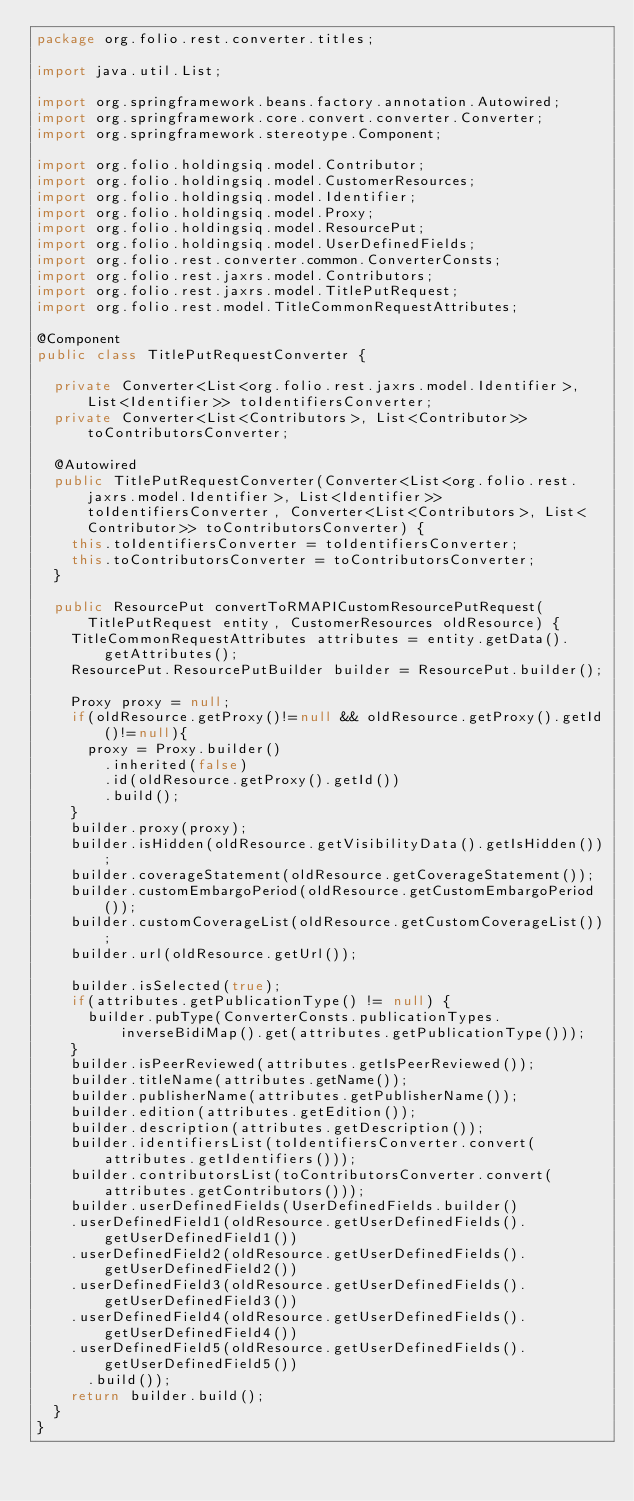Convert code to text. <code><loc_0><loc_0><loc_500><loc_500><_Java_>package org.folio.rest.converter.titles;

import java.util.List;

import org.springframework.beans.factory.annotation.Autowired;
import org.springframework.core.convert.converter.Converter;
import org.springframework.stereotype.Component;

import org.folio.holdingsiq.model.Contributor;
import org.folio.holdingsiq.model.CustomerResources;
import org.folio.holdingsiq.model.Identifier;
import org.folio.holdingsiq.model.Proxy;
import org.folio.holdingsiq.model.ResourcePut;
import org.folio.holdingsiq.model.UserDefinedFields;
import org.folio.rest.converter.common.ConverterConsts;
import org.folio.rest.jaxrs.model.Contributors;
import org.folio.rest.jaxrs.model.TitlePutRequest;
import org.folio.rest.model.TitleCommonRequestAttributes;

@Component
public class TitlePutRequestConverter {

  private Converter<List<org.folio.rest.jaxrs.model.Identifier>, List<Identifier>> toIdentifiersConverter;
  private Converter<List<Contributors>, List<Contributor>> toContributorsConverter;

  @Autowired
  public TitlePutRequestConverter(Converter<List<org.folio.rest.jaxrs.model.Identifier>, List<Identifier>> toIdentifiersConverter, Converter<List<Contributors>, List<Contributor>> toContributorsConverter) {
    this.toIdentifiersConverter = toIdentifiersConverter;
    this.toContributorsConverter = toContributorsConverter;
  }

  public ResourcePut convertToRMAPICustomResourcePutRequest(TitlePutRequest entity, CustomerResources oldResource) {
    TitleCommonRequestAttributes attributes = entity.getData().getAttributes();
    ResourcePut.ResourcePutBuilder builder = ResourcePut.builder();

    Proxy proxy = null;
    if(oldResource.getProxy()!=null && oldResource.getProxy().getId()!=null){
      proxy = Proxy.builder()
        .inherited(false)
        .id(oldResource.getProxy().getId())
        .build();
    }
    builder.proxy(proxy);
    builder.isHidden(oldResource.getVisibilityData().getIsHidden());
    builder.coverageStatement(oldResource.getCoverageStatement());
    builder.customEmbargoPeriod(oldResource.getCustomEmbargoPeriod());
    builder.customCoverageList(oldResource.getCustomCoverageList());
    builder.url(oldResource.getUrl());

    builder.isSelected(true);
    if(attributes.getPublicationType() != null) {
      builder.pubType(ConverterConsts.publicationTypes.inverseBidiMap().get(attributes.getPublicationType()));
    }
    builder.isPeerReviewed(attributes.getIsPeerReviewed());
    builder.titleName(attributes.getName());
    builder.publisherName(attributes.getPublisherName());
    builder.edition(attributes.getEdition());
    builder.description(attributes.getDescription());
    builder.identifiersList(toIdentifiersConverter.convert(attributes.getIdentifiers()));
    builder.contributorsList(toContributorsConverter.convert(attributes.getContributors()));
    builder.userDefinedFields(UserDefinedFields.builder()
    .userDefinedField1(oldResource.getUserDefinedFields().getUserDefinedField1())
    .userDefinedField2(oldResource.getUserDefinedFields().getUserDefinedField2())
    .userDefinedField3(oldResource.getUserDefinedFields().getUserDefinedField3())
    .userDefinedField4(oldResource.getUserDefinedFields().getUserDefinedField4())
    .userDefinedField5(oldResource.getUserDefinedFields().getUserDefinedField5())
      .build());
    return builder.build();
  }
}
</code> 